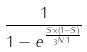Convert formula to latex. <formula><loc_0><loc_0><loc_500><loc_500>\frac { 1 } { 1 - e ^ { \frac { S \times ( 1 - S ) } { 3 ^ { N \cdot 1 } } } }</formula> 